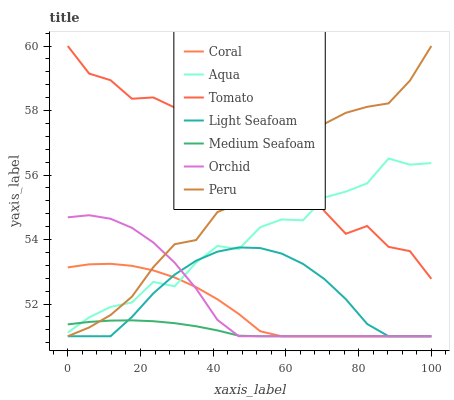Does Medium Seafoam have the minimum area under the curve?
Answer yes or no. Yes. Does Tomato have the maximum area under the curve?
Answer yes or no. Yes. Does Coral have the minimum area under the curve?
Answer yes or no. No. Does Coral have the maximum area under the curve?
Answer yes or no. No. Is Medium Seafoam the smoothest?
Answer yes or no. Yes. Is Tomato the roughest?
Answer yes or no. Yes. Is Coral the smoothest?
Answer yes or no. No. Is Coral the roughest?
Answer yes or no. No. Does Aqua have the lowest value?
Answer yes or no. No. Does Coral have the highest value?
Answer yes or no. No. Is Coral less than Tomato?
Answer yes or no. Yes. Is Tomato greater than Coral?
Answer yes or no. Yes. Does Coral intersect Tomato?
Answer yes or no. No. 